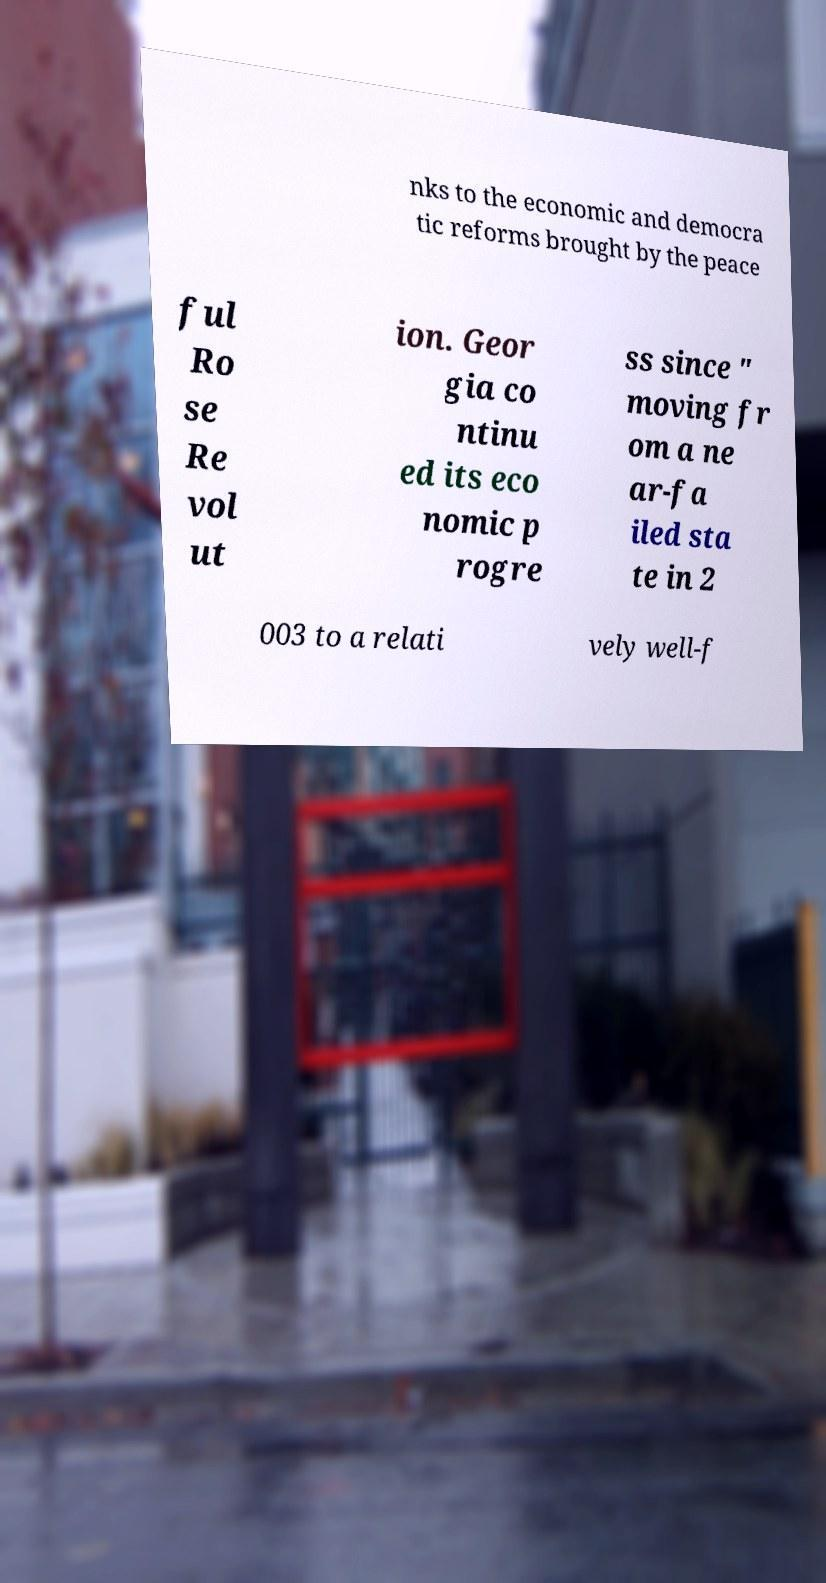What messages or text are displayed in this image? I need them in a readable, typed format. nks to the economic and democra tic reforms brought by the peace ful Ro se Re vol ut ion. Geor gia co ntinu ed its eco nomic p rogre ss since " moving fr om a ne ar-fa iled sta te in 2 003 to a relati vely well-f 